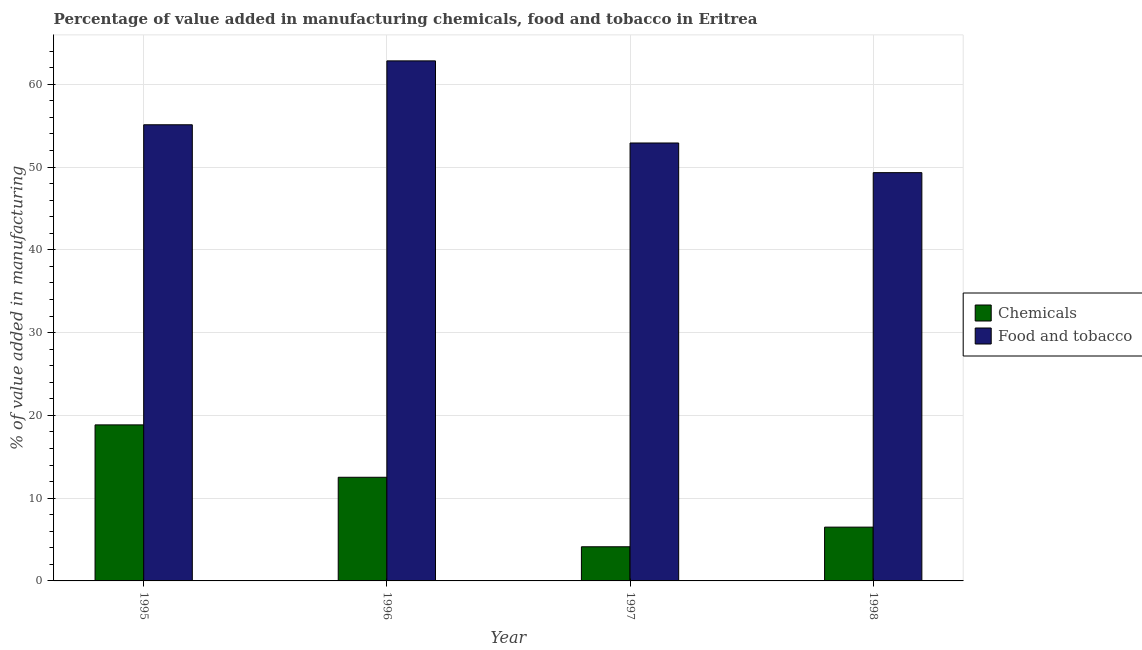How many bars are there on the 2nd tick from the right?
Ensure brevity in your answer.  2. What is the label of the 3rd group of bars from the left?
Offer a terse response. 1997. In how many cases, is the number of bars for a given year not equal to the number of legend labels?
Ensure brevity in your answer.  0. What is the value added by  manufacturing chemicals in 1996?
Provide a succinct answer. 12.52. Across all years, what is the maximum value added by  manufacturing chemicals?
Your answer should be very brief. 18.85. Across all years, what is the minimum value added by manufacturing food and tobacco?
Keep it short and to the point. 49.33. What is the total value added by  manufacturing chemicals in the graph?
Ensure brevity in your answer.  42. What is the difference between the value added by  manufacturing chemicals in 1996 and that in 1998?
Provide a short and direct response. 6.02. What is the difference between the value added by manufacturing food and tobacco in 1996 and the value added by  manufacturing chemicals in 1998?
Offer a very short reply. 13.5. What is the average value added by manufacturing food and tobacco per year?
Give a very brief answer. 55.05. In how many years, is the value added by manufacturing food and tobacco greater than 34 %?
Offer a terse response. 4. What is the ratio of the value added by manufacturing food and tobacco in 1996 to that in 1998?
Give a very brief answer. 1.27. Is the value added by  manufacturing chemicals in 1995 less than that in 1996?
Offer a terse response. No. Is the difference between the value added by  manufacturing chemicals in 1996 and 1997 greater than the difference between the value added by manufacturing food and tobacco in 1996 and 1997?
Provide a short and direct response. No. What is the difference between the highest and the second highest value added by manufacturing food and tobacco?
Make the answer very short. 7.72. What is the difference between the highest and the lowest value added by  manufacturing chemicals?
Offer a very short reply. 14.73. Is the sum of the value added by  manufacturing chemicals in 1996 and 1998 greater than the maximum value added by manufacturing food and tobacco across all years?
Offer a terse response. Yes. What does the 2nd bar from the left in 1997 represents?
Ensure brevity in your answer.  Food and tobacco. What does the 2nd bar from the right in 1998 represents?
Ensure brevity in your answer.  Chemicals. How many bars are there?
Offer a terse response. 8. Are all the bars in the graph horizontal?
Give a very brief answer. No. Are the values on the major ticks of Y-axis written in scientific E-notation?
Ensure brevity in your answer.  No. Does the graph contain any zero values?
Give a very brief answer. No. Does the graph contain grids?
Offer a very short reply. Yes. How many legend labels are there?
Make the answer very short. 2. How are the legend labels stacked?
Make the answer very short. Vertical. What is the title of the graph?
Make the answer very short. Percentage of value added in manufacturing chemicals, food and tobacco in Eritrea. What is the label or title of the Y-axis?
Make the answer very short. % of value added in manufacturing. What is the % of value added in manufacturing of Chemicals in 1995?
Provide a succinct answer. 18.85. What is the % of value added in manufacturing of Food and tobacco in 1995?
Offer a terse response. 55.11. What is the % of value added in manufacturing in Chemicals in 1996?
Provide a short and direct response. 12.52. What is the % of value added in manufacturing in Food and tobacco in 1996?
Your response must be concise. 62.83. What is the % of value added in manufacturing of Chemicals in 1997?
Provide a succinct answer. 4.13. What is the % of value added in manufacturing of Food and tobacco in 1997?
Your answer should be very brief. 52.91. What is the % of value added in manufacturing in Chemicals in 1998?
Provide a short and direct response. 6.5. What is the % of value added in manufacturing of Food and tobacco in 1998?
Keep it short and to the point. 49.33. Across all years, what is the maximum % of value added in manufacturing in Chemicals?
Provide a short and direct response. 18.85. Across all years, what is the maximum % of value added in manufacturing in Food and tobacco?
Offer a terse response. 62.83. Across all years, what is the minimum % of value added in manufacturing of Chemicals?
Offer a terse response. 4.13. Across all years, what is the minimum % of value added in manufacturing in Food and tobacco?
Offer a terse response. 49.33. What is the total % of value added in manufacturing in Chemicals in the graph?
Your response must be concise. 42. What is the total % of value added in manufacturing of Food and tobacco in the graph?
Your answer should be very brief. 220.19. What is the difference between the % of value added in manufacturing of Chemicals in 1995 and that in 1996?
Ensure brevity in your answer.  6.33. What is the difference between the % of value added in manufacturing of Food and tobacco in 1995 and that in 1996?
Offer a very short reply. -7.72. What is the difference between the % of value added in manufacturing of Chemicals in 1995 and that in 1997?
Provide a succinct answer. 14.73. What is the difference between the % of value added in manufacturing in Food and tobacco in 1995 and that in 1997?
Provide a succinct answer. 2.2. What is the difference between the % of value added in manufacturing of Chemicals in 1995 and that in 1998?
Your answer should be very brief. 12.35. What is the difference between the % of value added in manufacturing in Food and tobacco in 1995 and that in 1998?
Give a very brief answer. 5.79. What is the difference between the % of value added in manufacturing in Chemicals in 1996 and that in 1997?
Make the answer very short. 8.4. What is the difference between the % of value added in manufacturing in Food and tobacco in 1996 and that in 1997?
Give a very brief answer. 9.92. What is the difference between the % of value added in manufacturing of Chemicals in 1996 and that in 1998?
Ensure brevity in your answer.  6.02. What is the difference between the % of value added in manufacturing in Food and tobacco in 1996 and that in 1998?
Give a very brief answer. 13.5. What is the difference between the % of value added in manufacturing of Chemicals in 1997 and that in 1998?
Provide a short and direct response. -2.37. What is the difference between the % of value added in manufacturing in Food and tobacco in 1997 and that in 1998?
Your answer should be compact. 3.58. What is the difference between the % of value added in manufacturing in Chemicals in 1995 and the % of value added in manufacturing in Food and tobacco in 1996?
Provide a succinct answer. -43.98. What is the difference between the % of value added in manufacturing of Chemicals in 1995 and the % of value added in manufacturing of Food and tobacco in 1997?
Give a very brief answer. -34.06. What is the difference between the % of value added in manufacturing of Chemicals in 1995 and the % of value added in manufacturing of Food and tobacco in 1998?
Keep it short and to the point. -30.48. What is the difference between the % of value added in manufacturing in Chemicals in 1996 and the % of value added in manufacturing in Food and tobacco in 1997?
Offer a terse response. -40.39. What is the difference between the % of value added in manufacturing of Chemicals in 1996 and the % of value added in manufacturing of Food and tobacco in 1998?
Offer a terse response. -36.8. What is the difference between the % of value added in manufacturing in Chemicals in 1997 and the % of value added in manufacturing in Food and tobacco in 1998?
Provide a succinct answer. -45.2. What is the average % of value added in manufacturing of Chemicals per year?
Your response must be concise. 10.5. What is the average % of value added in manufacturing in Food and tobacco per year?
Your answer should be very brief. 55.05. In the year 1995, what is the difference between the % of value added in manufacturing of Chemicals and % of value added in manufacturing of Food and tobacco?
Offer a very short reply. -36.26. In the year 1996, what is the difference between the % of value added in manufacturing of Chemicals and % of value added in manufacturing of Food and tobacco?
Ensure brevity in your answer.  -50.31. In the year 1997, what is the difference between the % of value added in manufacturing in Chemicals and % of value added in manufacturing in Food and tobacco?
Your answer should be compact. -48.79. In the year 1998, what is the difference between the % of value added in manufacturing of Chemicals and % of value added in manufacturing of Food and tobacco?
Provide a succinct answer. -42.83. What is the ratio of the % of value added in manufacturing of Chemicals in 1995 to that in 1996?
Ensure brevity in your answer.  1.51. What is the ratio of the % of value added in manufacturing in Food and tobacco in 1995 to that in 1996?
Provide a short and direct response. 0.88. What is the ratio of the % of value added in manufacturing of Chemicals in 1995 to that in 1997?
Offer a terse response. 4.57. What is the ratio of the % of value added in manufacturing in Food and tobacco in 1995 to that in 1997?
Your answer should be compact. 1.04. What is the ratio of the % of value added in manufacturing of Chemicals in 1995 to that in 1998?
Provide a succinct answer. 2.9. What is the ratio of the % of value added in manufacturing in Food and tobacco in 1995 to that in 1998?
Your response must be concise. 1.12. What is the ratio of the % of value added in manufacturing in Chemicals in 1996 to that in 1997?
Provide a succinct answer. 3.04. What is the ratio of the % of value added in manufacturing of Food and tobacco in 1996 to that in 1997?
Provide a succinct answer. 1.19. What is the ratio of the % of value added in manufacturing of Chemicals in 1996 to that in 1998?
Offer a very short reply. 1.93. What is the ratio of the % of value added in manufacturing of Food and tobacco in 1996 to that in 1998?
Your answer should be compact. 1.27. What is the ratio of the % of value added in manufacturing in Chemicals in 1997 to that in 1998?
Keep it short and to the point. 0.63. What is the ratio of the % of value added in manufacturing of Food and tobacco in 1997 to that in 1998?
Offer a very short reply. 1.07. What is the difference between the highest and the second highest % of value added in manufacturing of Chemicals?
Give a very brief answer. 6.33. What is the difference between the highest and the second highest % of value added in manufacturing of Food and tobacco?
Your response must be concise. 7.72. What is the difference between the highest and the lowest % of value added in manufacturing of Chemicals?
Keep it short and to the point. 14.73. What is the difference between the highest and the lowest % of value added in manufacturing of Food and tobacco?
Offer a very short reply. 13.5. 